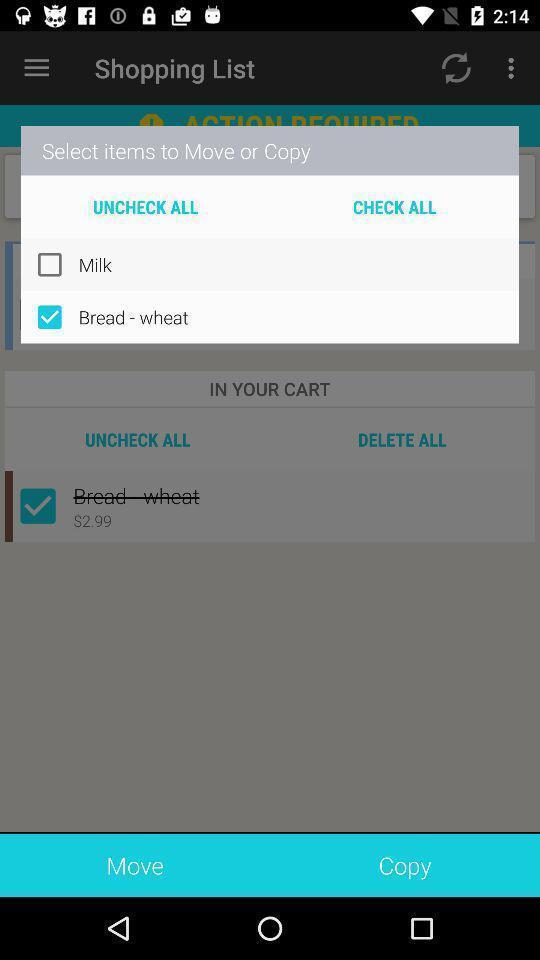Summarize the information in this screenshot. Pop-up shows select items in shopping app. 